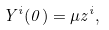<formula> <loc_0><loc_0><loc_500><loc_500>Y ^ { i } ( 0 ) = \mu z ^ { i } ,</formula> 